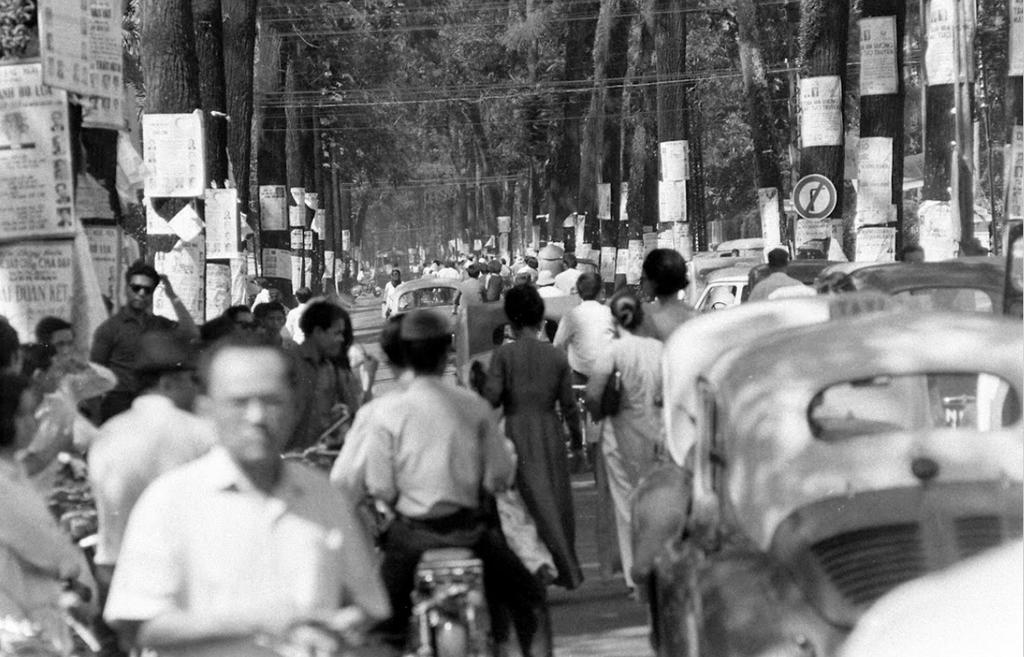What are the people in the image doing? The people in the image are walking. What else can be seen on the road in the image? There are cars on the road in the image. What type of natural elements are visible in the image? There are trees visible in the image. What is attached to the trees in the image? There are posters on the trees in the image. Can you see any wings or quills on the trees in the image? No, there are no wings or quills present on the trees in the image. Is there a volcano visible in the image? No, there is no volcano present in the image. 